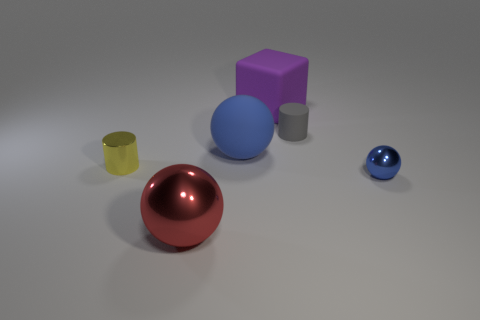What is the size of the thing that is both to the left of the purple cube and behind the yellow cylinder?
Provide a short and direct response. Large. Is the number of metal cylinders in front of the small ball greater than the number of blue spheres behind the yellow shiny object?
Offer a terse response. No. Is the shape of the yellow thing the same as the shiny object on the right side of the small gray cylinder?
Provide a succinct answer. No. How many other things are the same shape as the small gray object?
Provide a short and direct response. 1. There is a object that is both right of the big blue rubber ball and in front of the gray matte object; what color is it?
Ensure brevity in your answer.  Blue. What is the color of the matte cylinder?
Ensure brevity in your answer.  Gray. Does the purple thing have the same material as the ball in front of the tiny blue object?
Offer a terse response. No. The purple thing that is the same material as the gray cylinder is what shape?
Your answer should be compact. Cube. What color is the other cylinder that is the same size as the yellow cylinder?
Your answer should be compact. Gray. Do the shiny object that is right of the red ball and the tiny yellow cylinder have the same size?
Your response must be concise. Yes. 